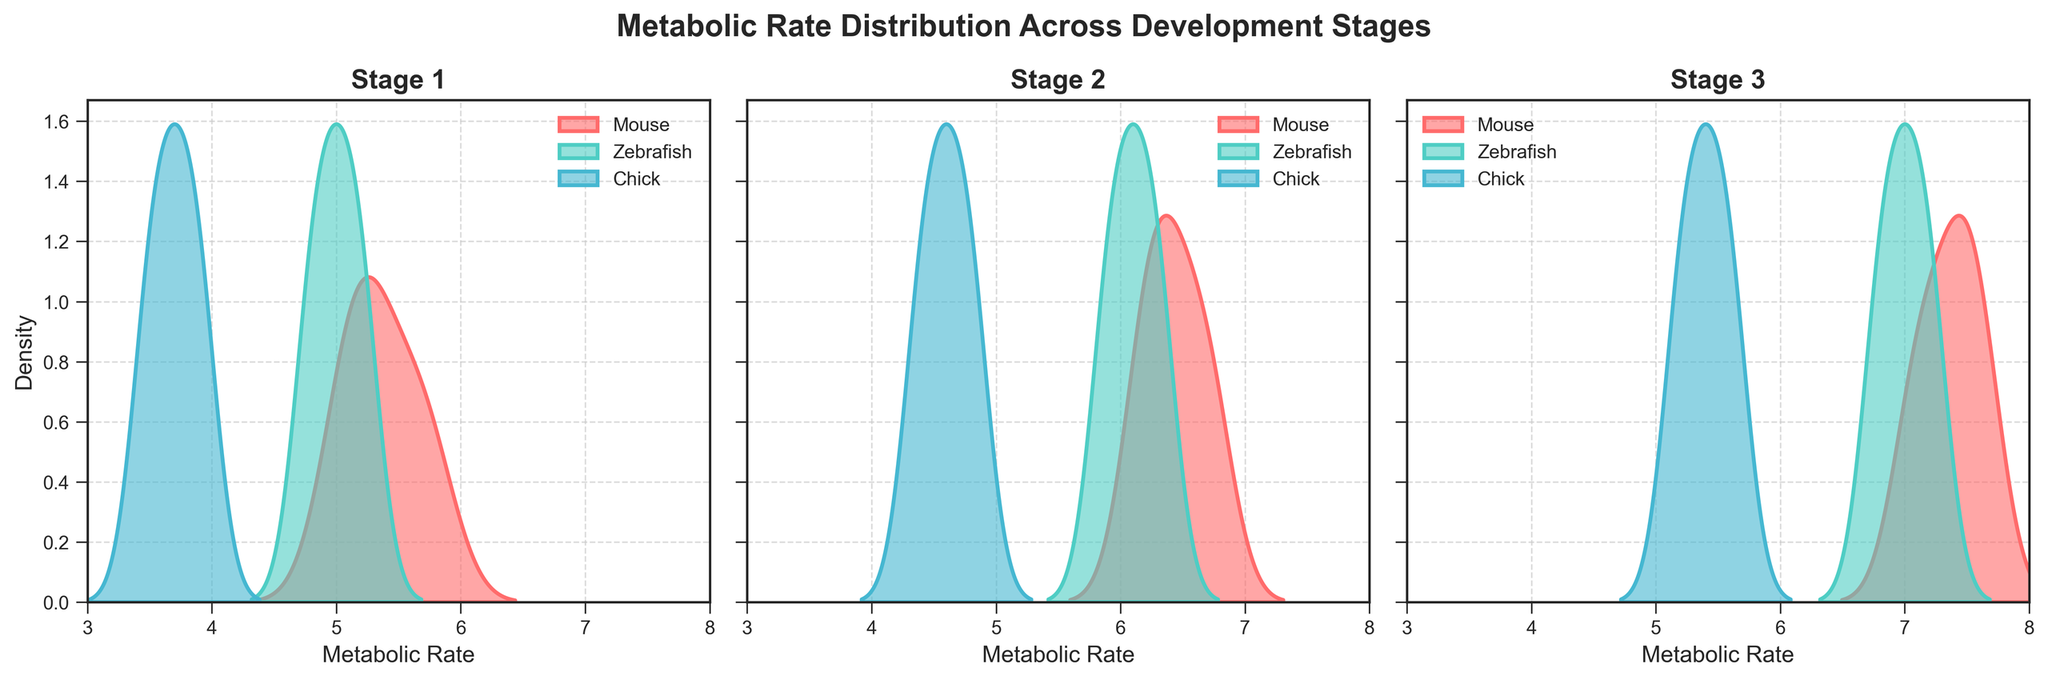What is the title of the figure? The title of the figure is displayed at the top center in bold letters. From the data and the code, we can see it is set as 'Metabolic Rate Distribution Across Development Stages'.
Answer: Metabolic Rate Distribution Across Development Stages Which species has the highest peak in Stage 2? To determine which species has the highest peak in Stage 2, look at the second subplot under 'Stage 2'. Identify the curve with the highest point.
Answer: Mouse How do the metabolic rates of Chick in Stage 1 compare to Stage 3? Compare the density plot peaks and ranges in the first subplot (Stage 1) and the third subplot (Stage 3) for the Chick species (typically in a distinct color). The Chick curve in Stage 1 has lower values concentrated around 3.5 to 3.9, while in Stage 3 it is higher, around 5.2 to 5.6.
Answer: Stage 3 rates are higher At which stage does Zebrafish show the greatest spread in metabolic rates? Assess the spread by observing the width of the density plots for Zebrafish across Stages 1, 2, and 3. The spread is indicated by the range the plot covers on the x-axis. In Stage 3, Zebrafish shows the widest range.
Answer: Stage 3 What is the range of metabolic rates for Mouse in Stage 1? Look at the density plot for Mouse in Stage 1. The plot starts just above 5.0 and ends at 5.7. Hence, the range can be calculated as 5.7 - 5.0.
Answer: 0.7 Which species shows the most noticeable increase in metabolic rate from Stage 1 to Stage 3? Examine the density plots across all three stages for each species. Note how the peak shifts to the right indicating an increase. Mouse shows the most noticeable increase in the metabolic rate from Stage 1 to Stage 3, as the peak shifts significantly to higher values.
Answer: Mouse How do the peak densities of all species in Stage 1 compare? Compare the height of the peaks in Stage 1 density plots for all three species. Stage 1 shows Chick with the lowest peak, Zebrafish with a moderate peak and Mouse with the highest peak.
Answer: Mouse > Zebrafish > Chick Which species has the narrowest distribution of metabolic rates in Stage 2? Determine the narrowest distribution by finding the density plot with the least width on the x-axis in Stage 2. Chick appears to have the narrowest distribution.
Answer: Chick What is the average metabolic rate for Zebrafish across all stages based on the peaks of the density plots? To find the average metabolic rate for Zebrafish, estimate the peak values from each stage, which are approximately 5.0 (Stage 1), 6.1 (Stage 2), and 7.0 (Stage 3). Average them: (5.0 + 6.1 + 7.0) / 3 = 6.03.
Answer: 6.03 